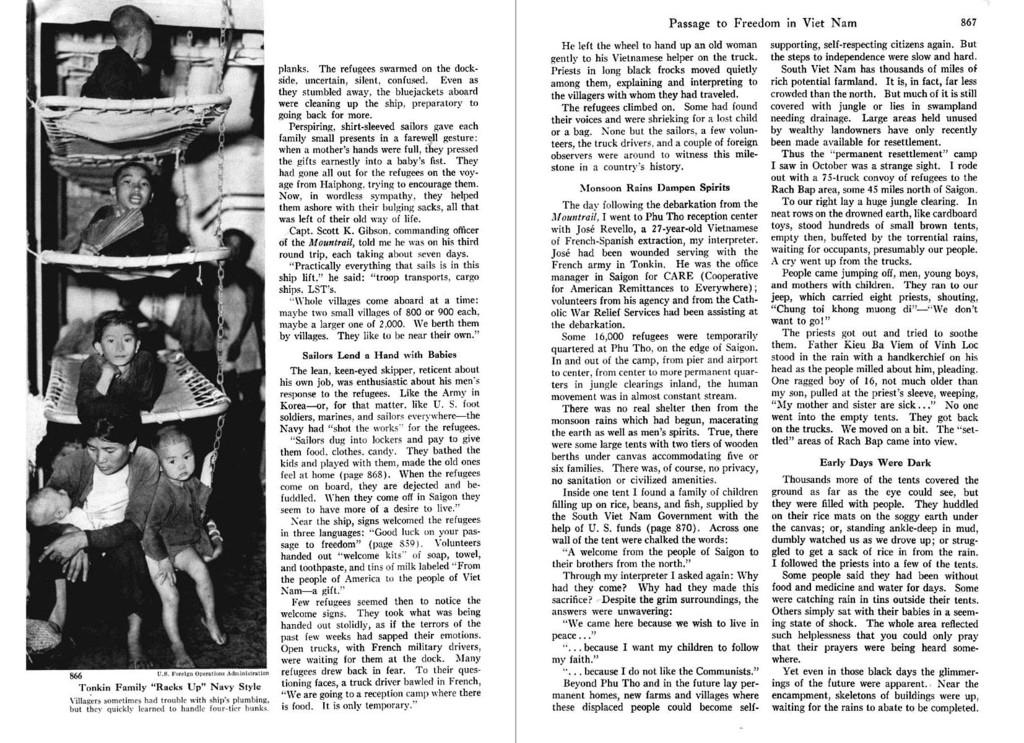What is present on the right side of the image? There is a poster on the right side of the image. What can be found on the poster? The poster has text on it and an image of persons. What is the main piece of furniture in the image? There is a bed in the image. Where is the image of persons located in relation to the bed? The image of persons is on the left side of the bed. What type of sack can be seen in the image? There is no sack present in the image. Are there any bears visible in the image? There are no bears present in the image. 